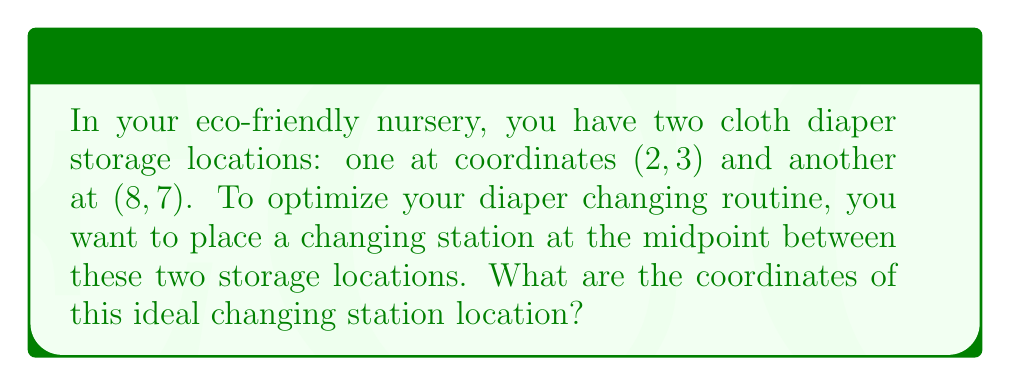Solve this math problem. To find the midpoint between two points, we use the midpoint formula:

$$ \text{Midpoint} = \left(\frac{x_1 + x_2}{2}, \frac{y_1 + y_2}{2}\right) $$

Where $(x_1, y_1)$ is the first point and $(x_2, y_2)$ is the second point.

Given:
- First storage location: $(2, 3)$
- Second storage location: $(8, 7)$

Step 1: Identify the x and y coordinates
$x_1 = 2, y_1 = 3$
$x_2 = 8, y_2 = 7$

Step 2: Apply the midpoint formula

For the x-coordinate:
$$ \frac{x_1 + x_2}{2} = \frac{2 + 8}{2} = \frac{10}{2} = 5 $$

For the y-coordinate:
$$ \frac{y_1 + y_2}{2} = \frac{3 + 7}{2} = \frac{10}{2} = 5 $$

Therefore, the midpoint coordinates are $(5, 5)$.
Answer: $(5, 5)$ 